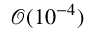<formula> <loc_0><loc_0><loc_500><loc_500>\mathcal { O } ( 1 0 ^ { - 4 } )</formula> 